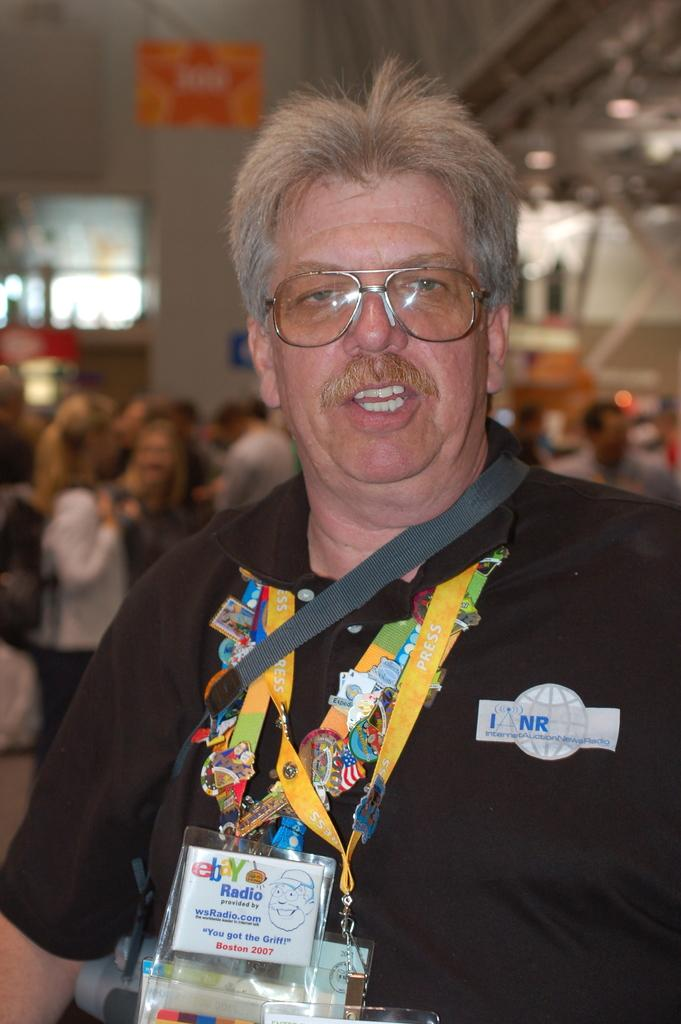What is the main subject of the image? There is a person in the image. What can be observed about the person's attire? The person is wearing tags and spectacles. Can you describe the background of the image? The background of the image is blurred. What is the price of the structure visible in the image? There is no structure visible in the image, and therefore no price can be determined. 